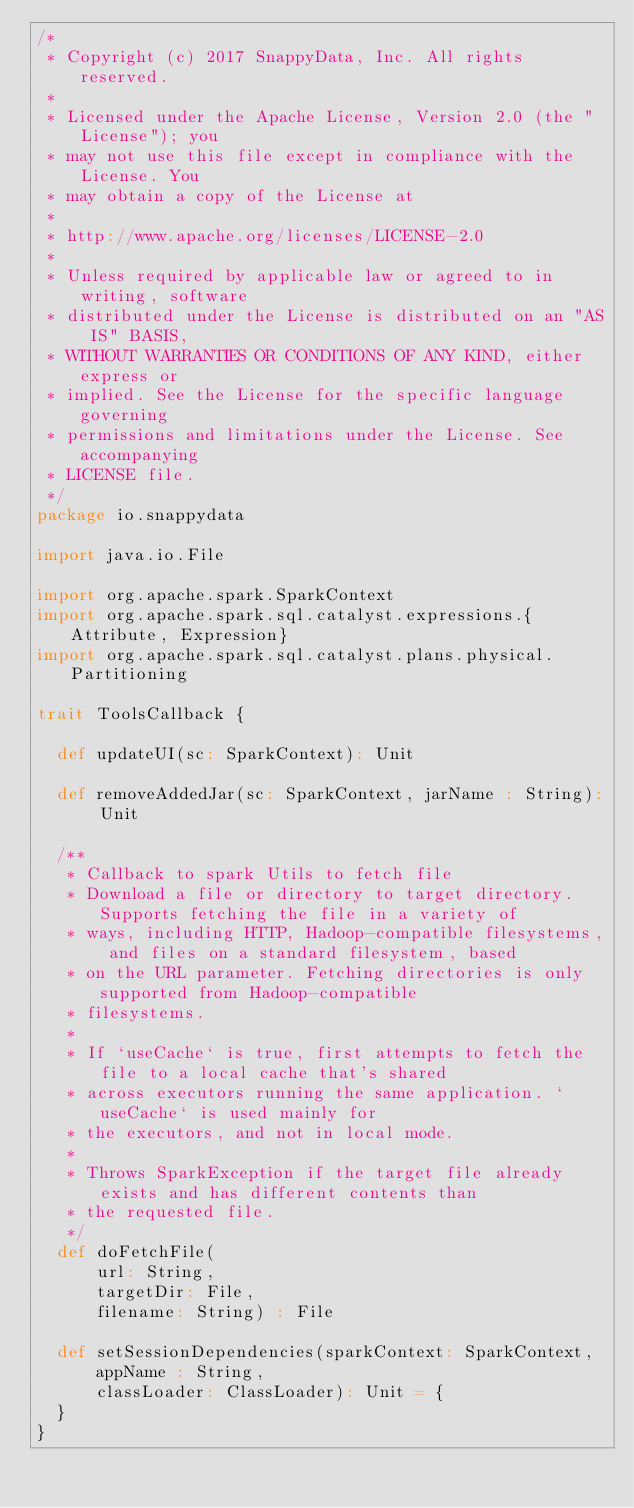<code> <loc_0><loc_0><loc_500><loc_500><_Scala_>/*
 * Copyright (c) 2017 SnappyData, Inc. All rights reserved.
 *
 * Licensed under the Apache License, Version 2.0 (the "License"); you
 * may not use this file except in compliance with the License. You
 * may obtain a copy of the License at
 *
 * http://www.apache.org/licenses/LICENSE-2.0
 *
 * Unless required by applicable law or agreed to in writing, software
 * distributed under the License is distributed on an "AS IS" BASIS,
 * WITHOUT WARRANTIES OR CONDITIONS OF ANY KIND, either express or
 * implied. See the License for the specific language governing
 * permissions and limitations under the License. See accompanying
 * LICENSE file.
 */
package io.snappydata

import java.io.File

import org.apache.spark.SparkContext
import org.apache.spark.sql.catalyst.expressions.{Attribute, Expression}
import org.apache.spark.sql.catalyst.plans.physical.Partitioning

trait ToolsCallback {

  def updateUI(sc: SparkContext): Unit

  def removeAddedJar(sc: SparkContext, jarName : String): Unit

  /**
   * Callback to spark Utils to fetch file
   * Download a file or directory to target directory. Supports fetching the file in a variety of
   * ways, including HTTP, Hadoop-compatible filesystems, and files on a standard filesystem, based
   * on the URL parameter. Fetching directories is only supported from Hadoop-compatible
   * filesystems.
   *
   * If `useCache` is true, first attempts to fetch the file to a local cache that's shared
   * across executors running the same application. `useCache` is used mainly for
   * the executors, and not in local mode.
   *
   * Throws SparkException if the target file already exists and has different contents than
   * the requested file.
   */
  def doFetchFile(
      url: String,
      targetDir: File,
      filename: String) : File

  def setSessionDependencies(sparkContext: SparkContext,
      appName : String,
      classLoader: ClassLoader): Unit = {
  }
}
</code> 